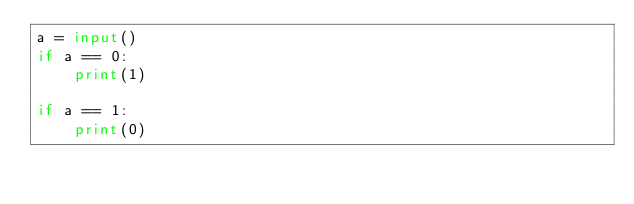<code> <loc_0><loc_0><loc_500><loc_500><_Python_>a = input()
if a == 0:
    print(1)

if a == 1:
    print(0)
</code> 